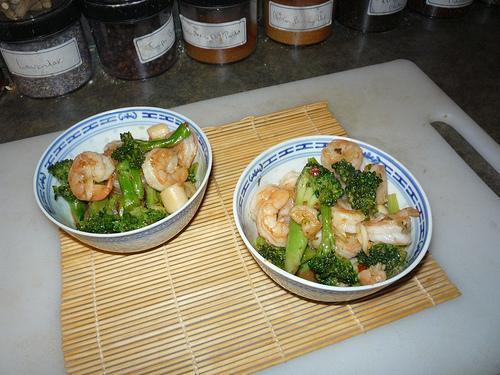How many bowls?
Give a very brief answer. 2. 